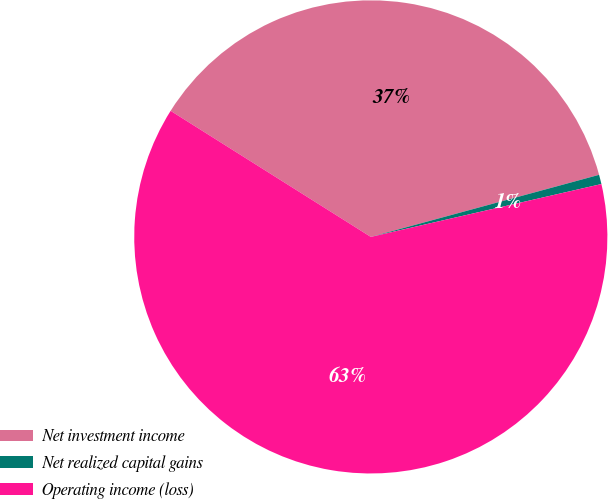Convert chart. <chart><loc_0><loc_0><loc_500><loc_500><pie_chart><fcel>Net investment income<fcel>Net realized capital gains<fcel>Operating income (loss)<nl><fcel>36.83%<fcel>0.64%<fcel>62.53%<nl></chart> 